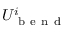<formula> <loc_0><loc_0><loc_500><loc_500>U _ { b e n d } ^ { i }</formula> 